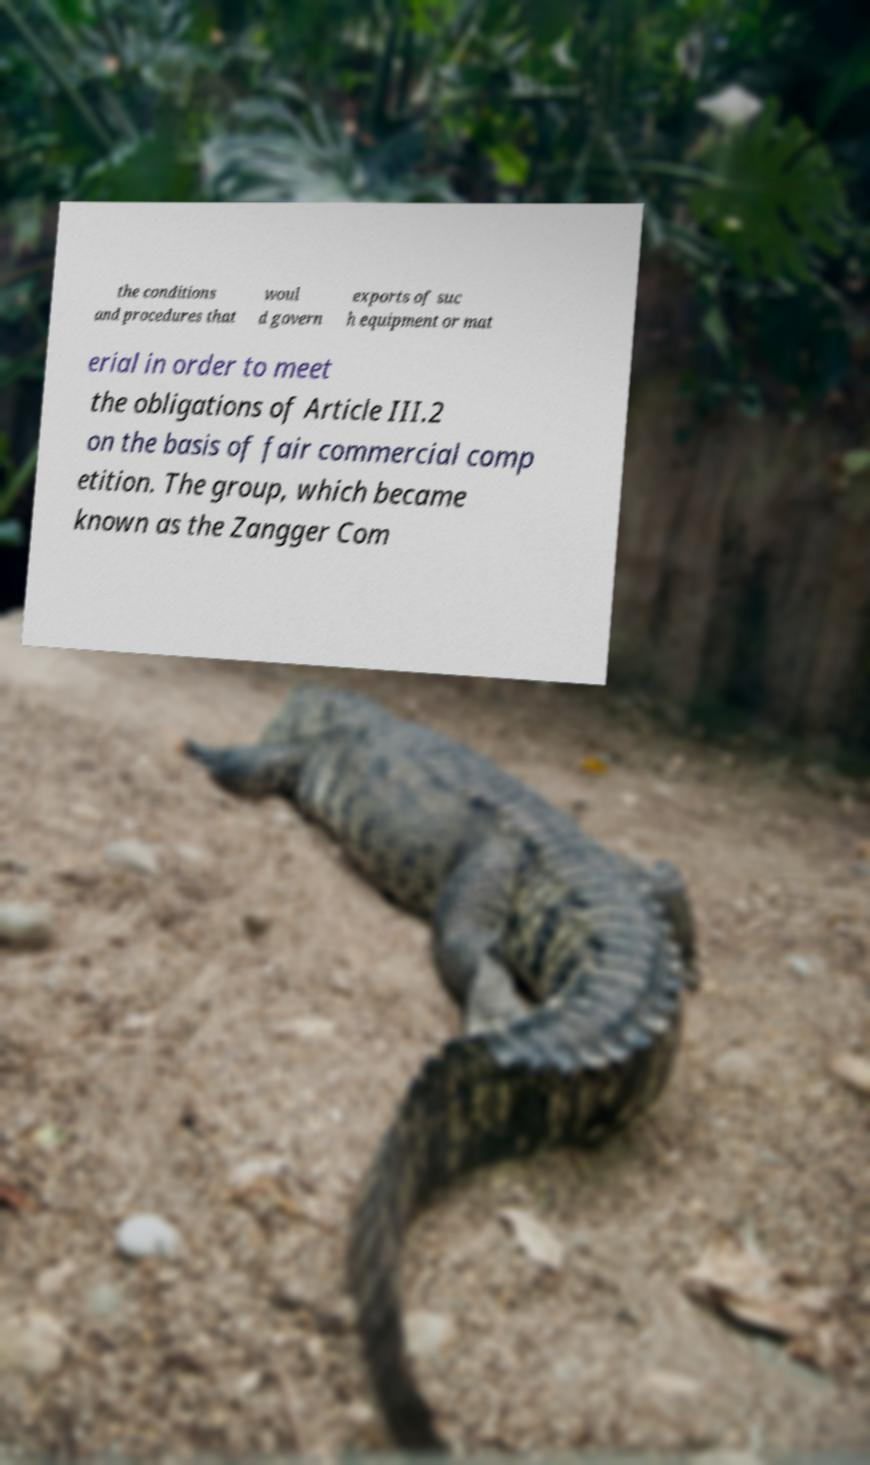Please read and relay the text visible in this image. What does it say? the conditions and procedures that woul d govern exports of suc h equipment or mat erial in order to meet the obligations of Article III.2 on the basis of fair commercial comp etition. The group, which became known as the Zangger Com 